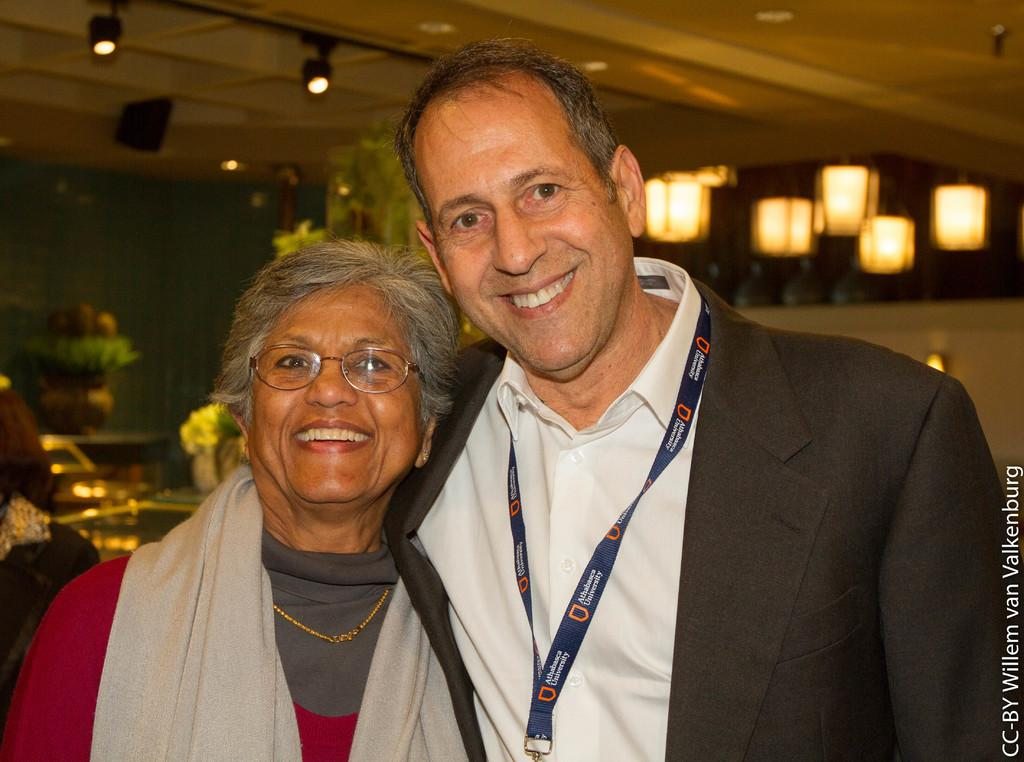How many people are in the image? There are two people standing in the image. What is the facial expression of the people in the image? The people are smiling. What type of decorative items can be seen in the image? There are flower pots in the image. What is visible above the people in the image? There is a ceiling visible in the image, and there are lights on the ceiling. What type of industry can be seen in the background of the image? There is no industry visible in the image; it only shows two people, flower pots, and a ceiling with lights. What position are the people in the image standing in? The image does not provide enough information to determine the exact position of the people, but they are both standing. 